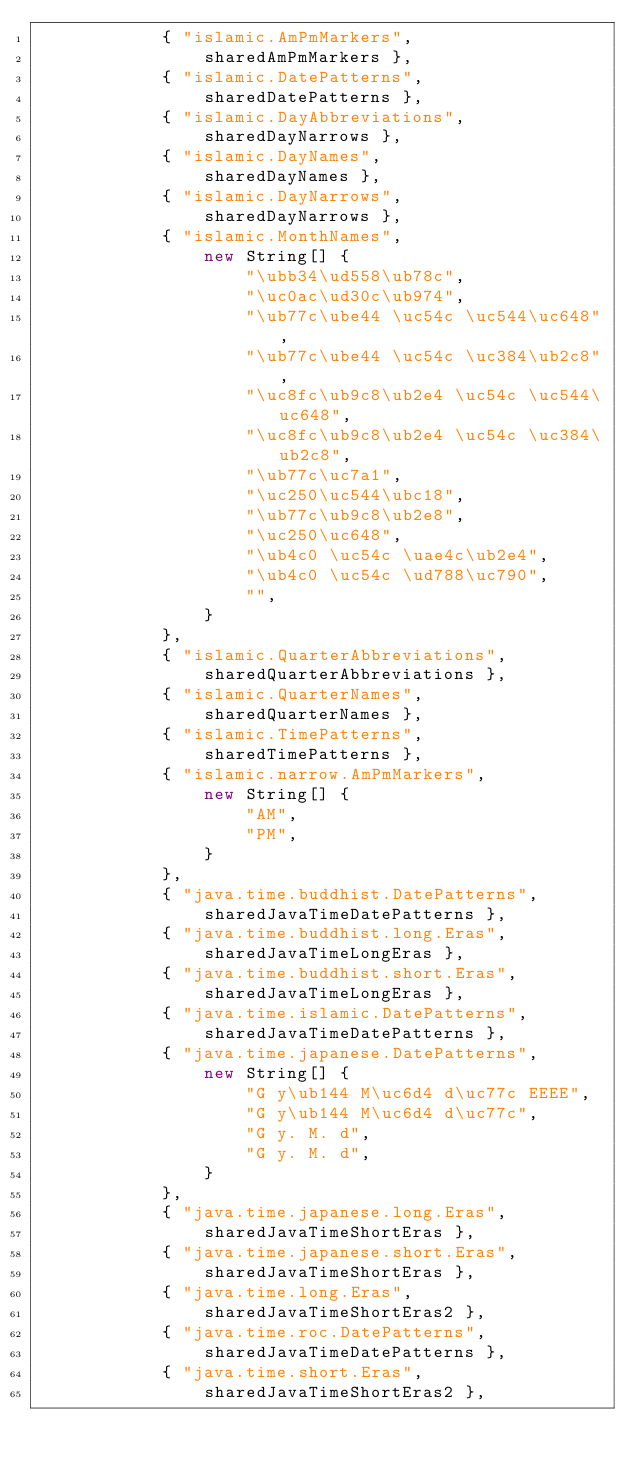<code> <loc_0><loc_0><loc_500><loc_500><_Java_>            { "islamic.AmPmMarkers",
                sharedAmPmMarkers },
            { "islamic.DatePatterns",
                sharedDatePatterns },
            { "islamic.DayAbbreviations",
                sharedDayNarrows },
            { "islamic.DayNames",
                sharedDayNames },
            { "islamic.DayNarrows",
                sharedDayNarrows },
            { "islamic.MonthNames",
                new String[] {
                    "\ubb34\ud558\ub78c",
                    "\uc0ac\ud30c\ub974",
                    "\ub77c\ube44 \uc54c \uc544\uc648",
                    "\ub77c\ube44 \uc54c \uc384\ub2c8",
                    "\uc8fc\ub9c8\ub2e4 \uc54c \uc544\uc648",
                    "\uc8fc\ub9c8\ub2e4 \uc54c \uc384\ub2c8",
                    "\ub77c\uc7a1",
                    "\uc250\uc544\ubc18",
                    "\ub77c\ub9c8\ub2e8",
                    "\uc250\uc648",
                    "\ub4c0 \uc54c \uae4c\ub2e4",
                    "\ub4c0 \uc54c \ud788\uc790",
                    "",
                }
            },
            { "islamic.QuarterAbbreviations",
                sharedQuarterAbbreviations },
            { "islamic.QuarterNames",
                sharedQuarterNames },
            { "islamic.TimePatterns",
                sharedTimePatterns },
            { "islamic.narrow.AmPmMarkers",
                new String[] {
                    "AM",
                    "PM",
                }
            },
            { "java.time.buddhist.DatePatterns",
                sharedJavaTimeDatePatterns },
            { "java.time.buddhist.long.Eras",
                sharedJavaTimeLongEras },
            { "java.time.buddhist.short.Eras",
                sharedJavaTimeLongEras },
            { "java.time.islamic.DatePatterns",
                sharedJavaTimeDatePatterns },
            { "java.time.japanese.DatePatterns",
                new String[] {
                    "G y\ub144 M\uc6d4 d\uc77c EEEE",
                    "G y\ub144 M\uc6d4 d\uc77c",
                    "G y. M. d",
                    "G y. M. d",
                }
            },
            { "java.time.japanese.long.Eras",
                sharedJavaTimeShortEras },
            { "java.time.japanese.short.Eras",
                sharedJavaTimeShortEras },
            { "java.time.long.Eras",
                sharedJavaTimeShortEras2 },
            { "java.time.roc.DatePatterns",
                sharedJavaTimeDatePatterns },
            { "java.time.short.Eras",
                sharedJavaTimeShortEras2 },</code> 